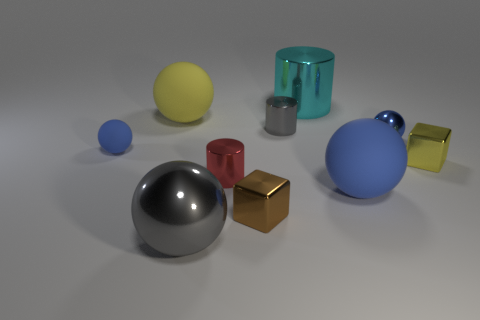Is the color of the small matte ball the same as the tiny shiny sphere?
Offer a terse response. Yes. Does the big sphere to the right of the tiny brown thing have the same color as the small matte sphere?
Your response must be concise. Yes. Is there a large yellow matte object that has the same shape as the tiny matte thing?
Provide a succinct answer. Yes. There is a matte thing that is the same size as the yellow cube; what is its color?
Your answer should be compact. Blue. How big is the blue matte thing that is right of the cyan metal thing?
Offer a very short reply. Large. Is there a gray metal cylinder that is behind the blue rubber sphere to the left of the tiny red metallic object?
Make the answer very short. Yes. Does the tiny ball left of the brown object have the same material as the gray cylinder?
Keep it short and to the point. No. What number of balls are both left of the large blue rubber thing and to the right of the yellow matte object?
Your answer should be very brief. 1. How many other large cylinders are the same material as the cyan cylinder?
Your response must be concise. 0. There is a large ball that is made of the same material as the tiny brown cube; what color is it?
Offer a very short reply. Gray. 